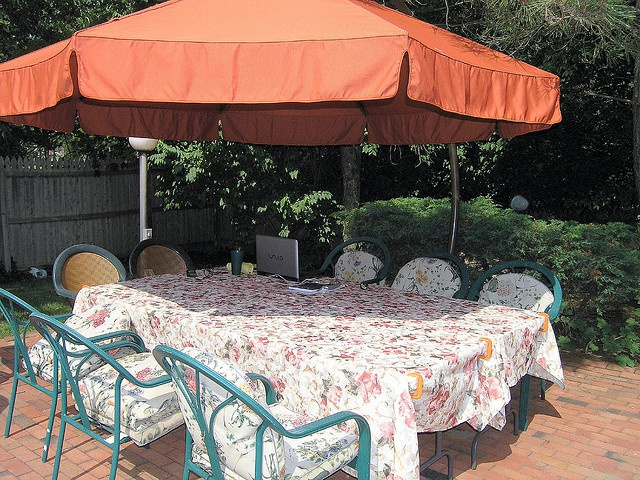Describe the objects in this image and their specific colors. I can see umbrella in black, salmon, and maroon tones, dining table in black, white, darkgray, gray, and pink tones, chair in black, lightgray, darkgray, teal, and gray tones, chair in black, ivory, darkgray, teal, and gray tones, and chair in black, teal, gray, and white tones in this image. 